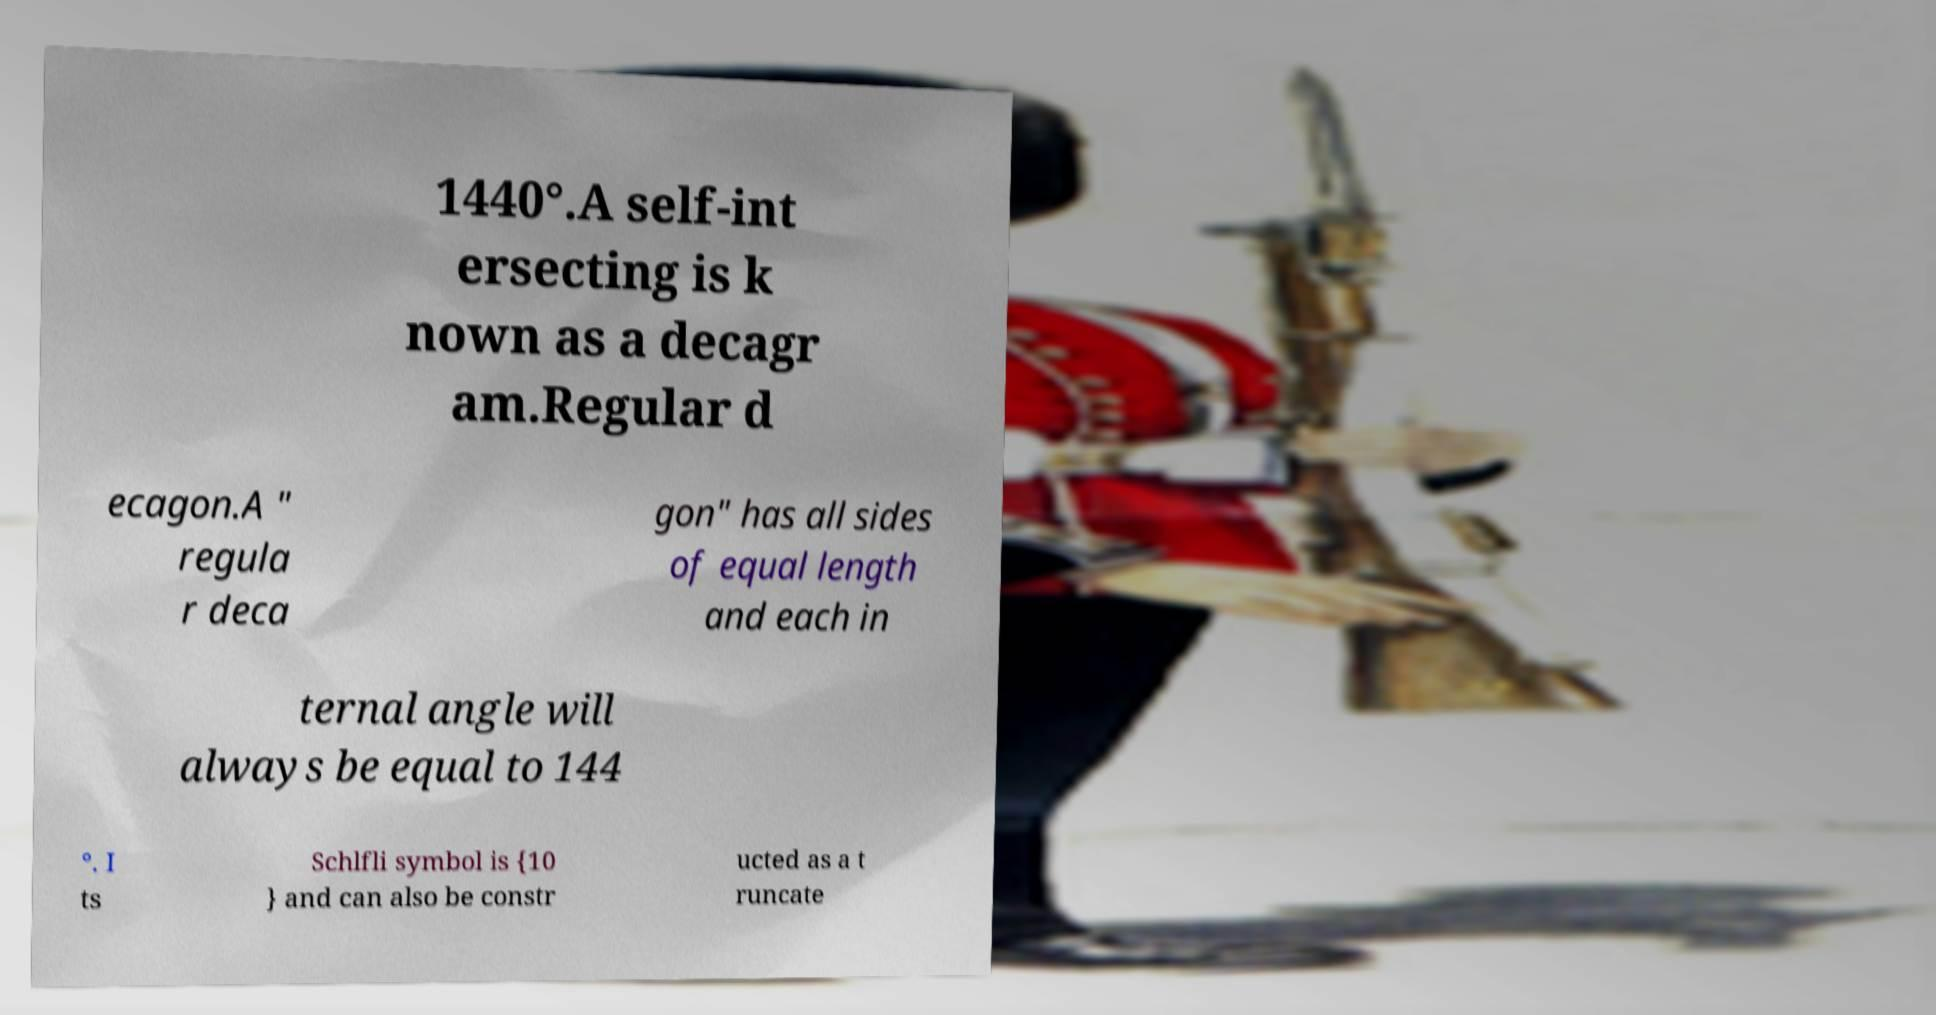For documentation purposes, I need the text within this image transcribed. Could you provide that? 1440°.A self-int ersecting is k nown as a decagr am.Regular d ecagon.A " regula r deca gon" has all sides of equal length and each in ternal angle will always be equal to 144 °. I ts Schlfli symbol is {10 } and can also be constr ucted as a t runcate 